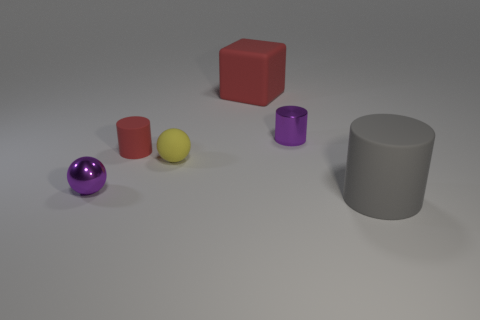Are there any red rubber things on the right side of the large gray matte object?
Ensure brevity in your answer.  No. Is the size of the red object behind the small red rubber cylinder the same as the gray object that is in front of the red block?
Provide a succinct answer. Yes. Is there a brown metal cylinder of the same size as the purple metallic cylinder?
Make the answer very short. No. There is a red rubber thing that is left of the yellow matte object; does it have the same shape as the gray rubber thing?
Your answer should be compact. Yes. There is a tiny object that is to the right of the tiny matte ball; what material is it?
Your answer should be compact. Metal. What shape is the purple object in front of the shiny thing that is on the right side of the red rubber cylinder?
Ensure brevity in your answer.  Sphere. Do the big gray object and the small shiny thing in front of the yellow object have the same shape?
Keep it short and to the point. No. How many big gray cylinders are behind the red thing that is behind the small purple shiny cylinder?
Offer a very short reply. 0. There is a tiny purple object that is the same shape as the gray object; what material is it?
Your response must be concise. Metal. What number of red things are tiny metallic spheres or matte spheres?
Ensure brevity in your answer.  0. 